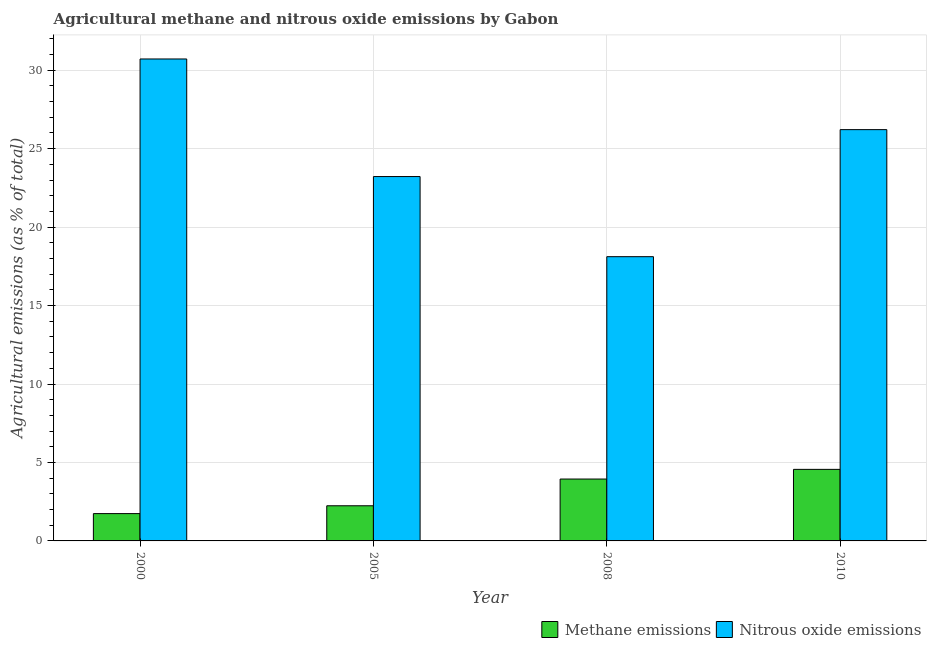How many different coloured bars are there?
Your response must be concise. 2. How many groups of bars are there?
Keep it short and to the point. 4. Are the number of bars per tick equal to the number of legend labels?
Your response must be concise. Yes. How many bars are there on the 4th tick from the left?
Offer a very short reply. 2. How many bars are there on the 2nd tick from the right?
Your answer should be very brief. 2. In how many cases, is the number of bars for a given year not equal to the number of legend labels?
Offer a very short reply. 0. What is the amount of methane emissions in 2008?
Offer a terse response. 3.94. Across all years, what is the maximum amount of nitrous oxide emissions?
Offer a terse response. 30.72. Across all years, what is the minimum amount of methane emissions?
Offer a very short reply. 1.74. In which year was the amount of methane emissions maximum?
Offer a terse response. 2010. What is the total amount of methane emissions in the graph?
Provide a short and direct response. 12.49. What is the difference between the amount of nitrous oxide emissions in 2005 and that in 2010?
Ensure brevity in your answer.  -2.99. What is the difference between the amount of methane emissions in 2000 and the amount of nitrous oxide emissions in 2008?
Make the answer very short. -2.2. What is the average amount of nitrous oxide emissions per year?
Provide a short and direct response. 24.57. In the year 2010, what is the difference between the amount of nitrous oxide emissions and amount of methane emissions?
Your answer should be very brief. 0. What is the ratio of the amount of nitrous oxide emissions in 2005 to that in 2010?
Make the answer very short. 0.89. Is the amount of nitrous oxide emissions in 2008 less than that in 2010?
Offer a terse response. Yes. Is the difference between the amount of nitrous oxide emissions in 2005 and 2008 greater than the difference between the amount of methane emissions in 2005 and 2008?
Make the answer very short. No. What is the difference between the highest and the second highest amount of methane emissions?
Offer a very short reply. 0.62. What is the difference between the highest and the lowest amount of nitrous oxide emissions?
Ensure brevity in your answer.  12.6. In how many years, is the amount of nitrous oxide emissions greater than the average amount of nitrous oxide emissions taken over all years?
Ensure brevity in your answer.  2. What does the 2nd bar from the left in 2008 represents?
Make the answer very short. Nitrous oxide emissions. What does the 1st bar from the right in 2010 represents?
Your response must be concise. Nitrous oxide emissions. Are all the bars in the graph horizontal?
Keep it short and to the point. No. How many years are there in the graph?
Offer a very short reply. 4. What is the difference between two consecutive major ticks on the Y-axis?
Ensure brevity in your answer.  5. Are the values on the major ticks of Y-axis written in scientific E-notation?
Your answer should be very brief. No. Does the graph contain any zero values?
Keep it short and to the point. No. Does the graph contain grids?
Provide a short and direct response. Yes. How are the legend labels stacked?
Make the answer very short. Horizontal. What is the title of the graph?
Give a very brief answer. Agricultural methane and nitrous oxide emissions by Gabon. What is the label or title of the Y-axis?
Give a very brief answer. Agricultural emissions (as % of total). What is the Agricultural emissions (as % of total) of Methane emissions in 2000?
Give a very brief answer. 1.74. What is the Agricultural emissions (as % of total) in Nitrous oxide emissions in 2000?
Provide a short and direct response. 30.72. What is the Agricultural emissions (as % of total) in Methane emissions in 2005?
Offer a very short reply. 2.24. What is the Agricultural emissions (as % of total) of Nitrous oxide emissions in 2005?
Your answer should be very brief. 23.22. What is the Agricultural emissions (as % of total) of Methane emissions in 2008?
Provide a short and direct response. 3.94. What is the Agricultural emissions (as % of total) in Nitrous oxide emissions in 2008?
Make the answer very short. 18.12. What is the Agricultural emissions (as % of total) in Methane emissions in 2010?
Provide a short and direct response. 4.56. What is the Agricultural emissions (as % of total) of Nitrous oxide emissions in 2010?
Offer a very short reply. 26.21. Across all years, what is the maximum Agricultural emissions (as % of total) of Methane emissions?
Keep it short and to the point. 4.56. Across all years, what is the maximum Agricultural emissions (as % of total) in Nitrous oxide emissions?
Your answer should be very brief. 30.72. Across all years, what is the minimum Agricultural emissions (as % of total) in Methane emissions?
Your answer should be compact. 1.74. Across all years, what is the minimum Agricultural emissions (as % of total) of Nitrous oxide emissions?
Provide a short and direct response. 18.12. What is the total Agricultural emissions (as % of total) of Methane emissions in the graph?
Your response must be concise. 12.49. What is the total Agricultural emissions (as % of total) of Nitrous oxide emissions in the graph?
Offer a very short reply. 98.27. What is the difference between the Agricultural emissions (as % of total) in Methane emissions in 2000 and that in 2005?
Provide a short and direct response. -0.5. What is the difference between the Agricultural emissions (as % of total) in Nitrous oxide emissions in 2000 and that in 2005?
Your response must be concise. 7.49. What is the difference between the Agricultural emissions (as % of total) in Methane emissions in 2000 and that in 2008?
Offer a terse response. -2.2. What is the difference between the Agricultural emissions (as % of total) of Nitrous oxide emissions in 2000 and that in 2008?
Keep it short and to the point. 12.6. What is the difference between the Agricultural emissions (as % of total) in Methane emissions in 2000 and that in 2010?
Your answer should be very brief. -2.82. What is the difference between the Agricultural emissions (as % of total) in Nitrous oxide emissions in 2000 and that in 2010?
Your answer should be very brief. 4.5. What is the difference between the Agricultural emissions (as % of total) of Methane emissions in 2005 and that in 2008?
Offer a terse response. -1.7. What is the difference between the Agricultural emissions (as % of total) of Nitrous oxide emissions in 2005 and that in 2008?
Ensure brevity in your answer.  5.11. What is the difference between the Agricultural emissions (as % of total) in Methane emissions in 2005 and that in 2010?
Your answer should be compact. -2.32. What is the difference between the Agricultural emissions (as % of total) in Nitrous oxide emissions in 2005 and that in 2010?
Your answer should be compact. -2.99. What is the difference between the Agricultural emissions (as % of total) of Methane emissions in 2008 and that in 2010?
Your answer should be compact. -0.62. What is the difference between the Agricultural emissions (as % of total) in Nitrous oxide emissions in 2008 and that in 2010?
Offer a very short reply. -8.1. What is the difference between the Agricultural emissions (as % of total) of Methane emissions in 2000 and the Agricultural emissions (as % of total) of Nitrous oxide emissions in 2005?
Provide a short and direct response. -21.48. What is the difference between the Agricultural emissions (as % of total) in Methane emissions in 2000 and the Agricultural emissions (as % of total) in Nitrous oxide emissions in 2008?
Give a very brief answer. -16.38. What is the difference between the Agricultural emissions (as % of total) of Methane emissions in 2000 and the Agricultural emissions (as % of total) of Nitrous oxide emissions in 2010?
Your answer should be very brief. -24.47. What is the difference between the Agricultural emissions (as % of total) in Methane emissions in 2005 and the Agricultural emissions (as % of total) in Nitrous oxide emissions in 2008?
Give a very brief answer. -15.88. What is the difference between the Agricultural emissions (as % of total) of Methane emissions in 2005 and the Agricultural emissions (as % of total) of Nitrous oxide emissions in 2010?
Keep it short and to the point. -23.97. What is the difference between the Agricultural emissions (as % of total) in Methane emissions in 2008 and the Agricultural emissions (as % of total) in Nitrous oxide emissions in 2010?
Offer a terse response. -22.27. What is the average Agricultural emissions (as % of total) in Methane emissions per year?
Your answer should be compact. 3.12. What is the average Agricultural emissions (as % of total) in Nitrous oxide emissions per year?
Give a very brief answer. 24.57. In the year 2000, what is the difference between the Agricultural emissions (as % of total) of Methane emissions and Agricultural emissions (as % of total) of Nitrous oxide emissions?
Offer a very short reply. -28.98. In the year 2005, what is the difference between the Agricultural emissions (as % of total) in Methane emissions and Agricultural emissions (as % of total) in Nitrous oxide emissions?
Make the answer very short. -20.98. In the year 2008, what is the difference between the Agricultural emissions (as % of total) of Methane emissions and Agricultural emissions (as % of total) of Nitrous oxide emissions?
Give a very brief answer. -14.17. In the year 2010, what is the difference between the Agricultural emissions (as % of total) in Methane emissions and Agricultural emissions (as % of total) in Nitrous oxide emissions?
Keep it short and to the point. -21.65. What is the ratio of the Agricultural emissions (as % of total) of Methane emissions in 2000 to that in 2005?
Keep it short and to the point. 0.78. What is the ratio of the Agricultural emissions (as % of total) in Nitrous oxide emissions in 2000 to that in 2005?
Make the answer very short. 1.32. What is the ratio of the Agricultural emissions (as % of total) in Methane emissions in 2000 to that in 2008?
Your answer should be compact. 0.44. What is the ratio of the Agricultural emissions (as % of total) in Nitrous oxide emissions in 2000 to that in 2008?
Your answer should be compact. 1.7. What is the ratio of the Agricultural emissions (as % of total) in Methane emissions in 2000 to that in 2010?
Ensure brevity in your answer.  0.38. What is the ratio of the Agricultural emissions (as % of total) of Nitrous oxide emissions in 2000 to that in 2010?
Ensure brevity in your answer.  1.17. What is the ratio of the Agricultural emissions (as % of total) of Methane emissions in 2005 to that in 2008?
Keep it short and to the point. 0.57. What is the ratio of the Agricultural emissions (as % of total) in Nitrous oxide emissions in 2005 to that in 2008?
Offer a very short reply. 1.28. What is the ratio of the Agricultural emissions (as % of total) of Methane emissions in 2005 to that in 2010?
Your answer should be compact. 0.49. What is the ratio of the Agricultural emissions (as % of total) of Nitrous oxide emissions in 2005 to that in 2010?
Make the answer very short. 0.89. What is the ratio of the Agricultural emissions (as % of total) of Methane emissions in 2008 to that in 2010?
Offer a terse response. 0.86. What is the ratio of the Agricultural emissions (as % of total) of Nitrous oxide emissions in 2008 to that in 2010?
Offer a terse response. 0.69. What is the difference between the highest and the second highest Agricultural emissions (as % of total) of Methane emissions?
Keep it short and to the point. 0.62. What is the difference between the highest and the second highest Agricultural emissions (as % of total) of Nitrous oxide emissions?
Make the answer very short. 4.5. What is the difference between the highest and the lowest Agricultural emissions (as % of total) in Methane emissions?
Keep it short and to the point. 2.82. What is the difference between the highest and the lowest Agricultural emissions (as % of total) in Nitrous oxide emissions?
Keep it short and to the point. 12.6. 